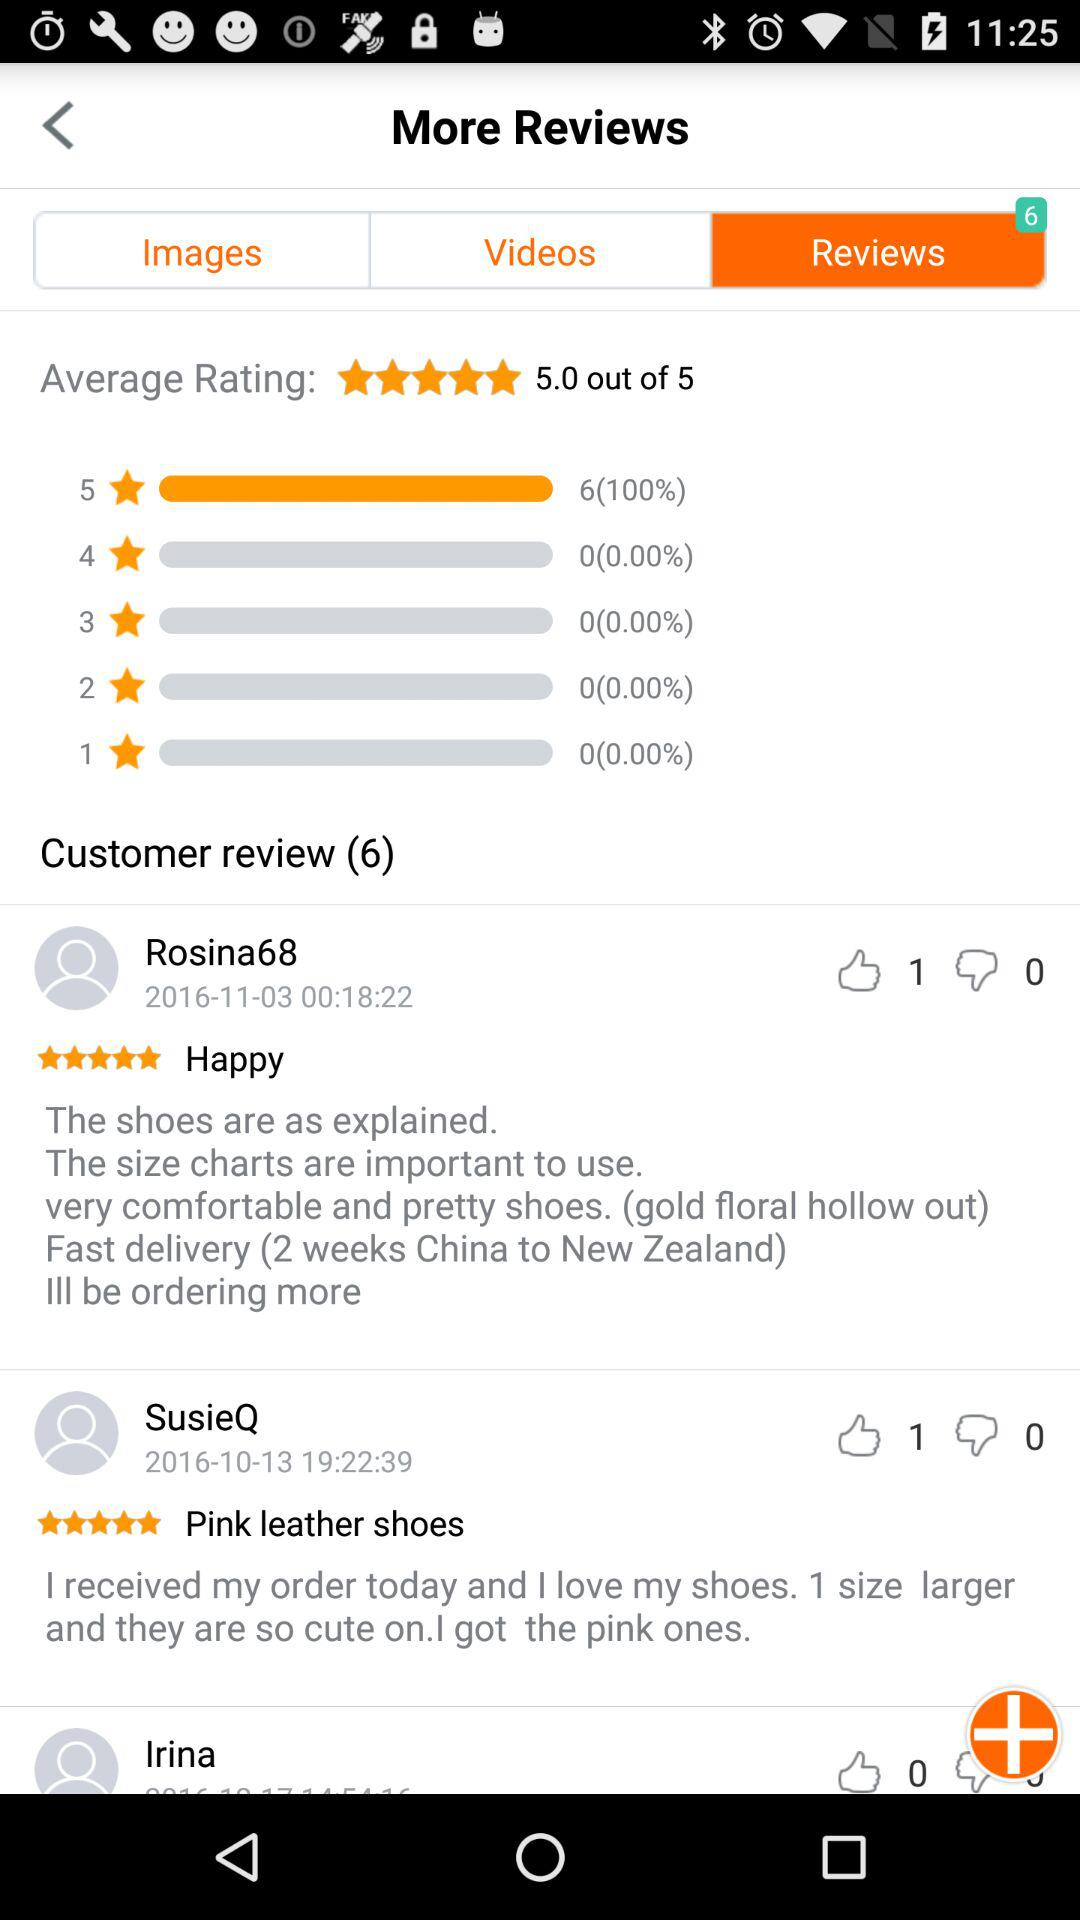On which date did "Rosina68" give a review? "Rosina68" gave a review on November 3, 2016. 